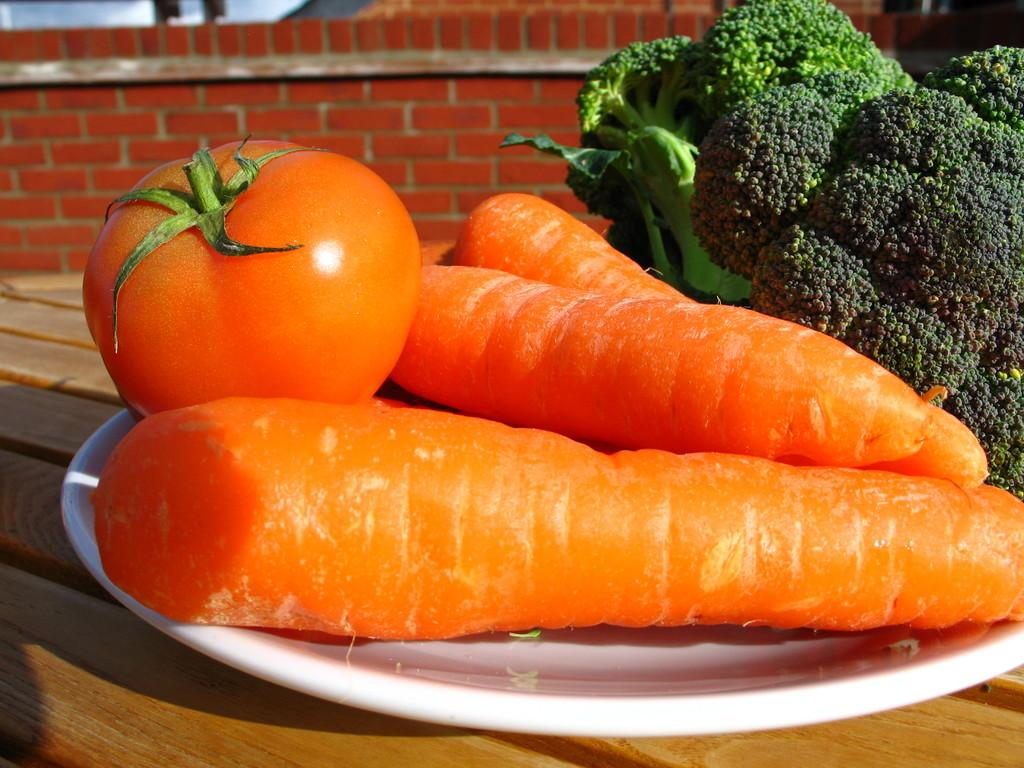What type of vegetables can be seen in the image? There are tomatoes, carrots, and broccoli in the image. How are the vegetables arranged in the image? The vegetables are in a plate in the image. Where is the plate with vegetables located? The plate is placed on a table in the image. What can be seen in the background of the image? There is a wall visible in the background of the image. How many volcanoes can be seen erupting in the image? There are no volcanoes present in the image. What type of division is being performed on the vegetables in the image? There is no division being performed on the vegetables in the image. 